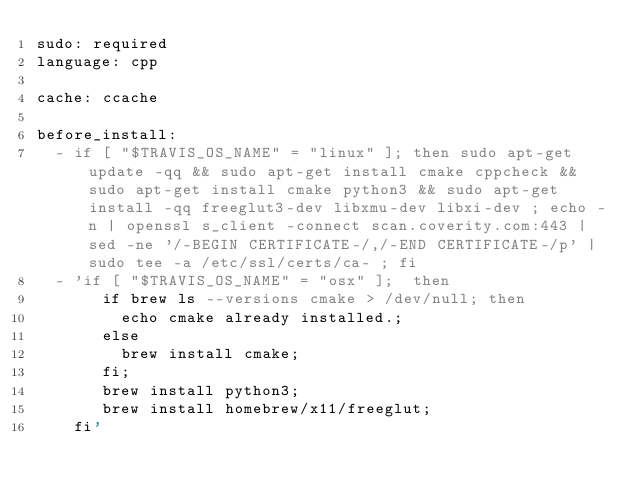Convert code to text. <code><loc_0><loc_0><loc_500><loc_500><_YAML_>sudo: required
language: cpp

cache: ccache

before_install:
  - if [ "$TRAVIS_OS_NAME" = "linux" ]; then sudo apt-get update -qq && sudo apt-get install cmake cppcheck && sudo apt-get install cmake python3 && sudo apt-get install -qq freeglut3-dev libxmu-dev libxi-dev ; echo -n | openssl s_client -connect scan.coverity.com:443 | sed -ne '/-BEGIN CERTIFICATE-/,/-END CERTIFICATE-/p' | sudo tee -a /etc/ssl/certs/ca- ; fi
  - 'if [ "$TRAVIS_OS_NAME" = "osx" ];  then
       if brew ls --versions cmake > /dev/null; then
         echo cmake already installed.;
       else
         brew install cmake;
       fi;
       brew install python3;
       brew install homebrew/x11/freeglut; 
    fi'</code> 